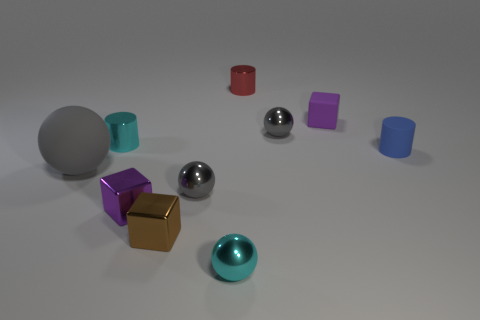Are there any objects that seem reflective, and if so, which ones? Indeed, there are reflective objects in the image. The two spheres, one silver and one chrome, both exhibit reflective surfaces. Can you tell me more about the reflections in the spheres? Certainly! The silver sphere has reflections that hint at a light source above, while the chrome sphere shows reflections of the surrounding objects, indicating a highly polished surface. 